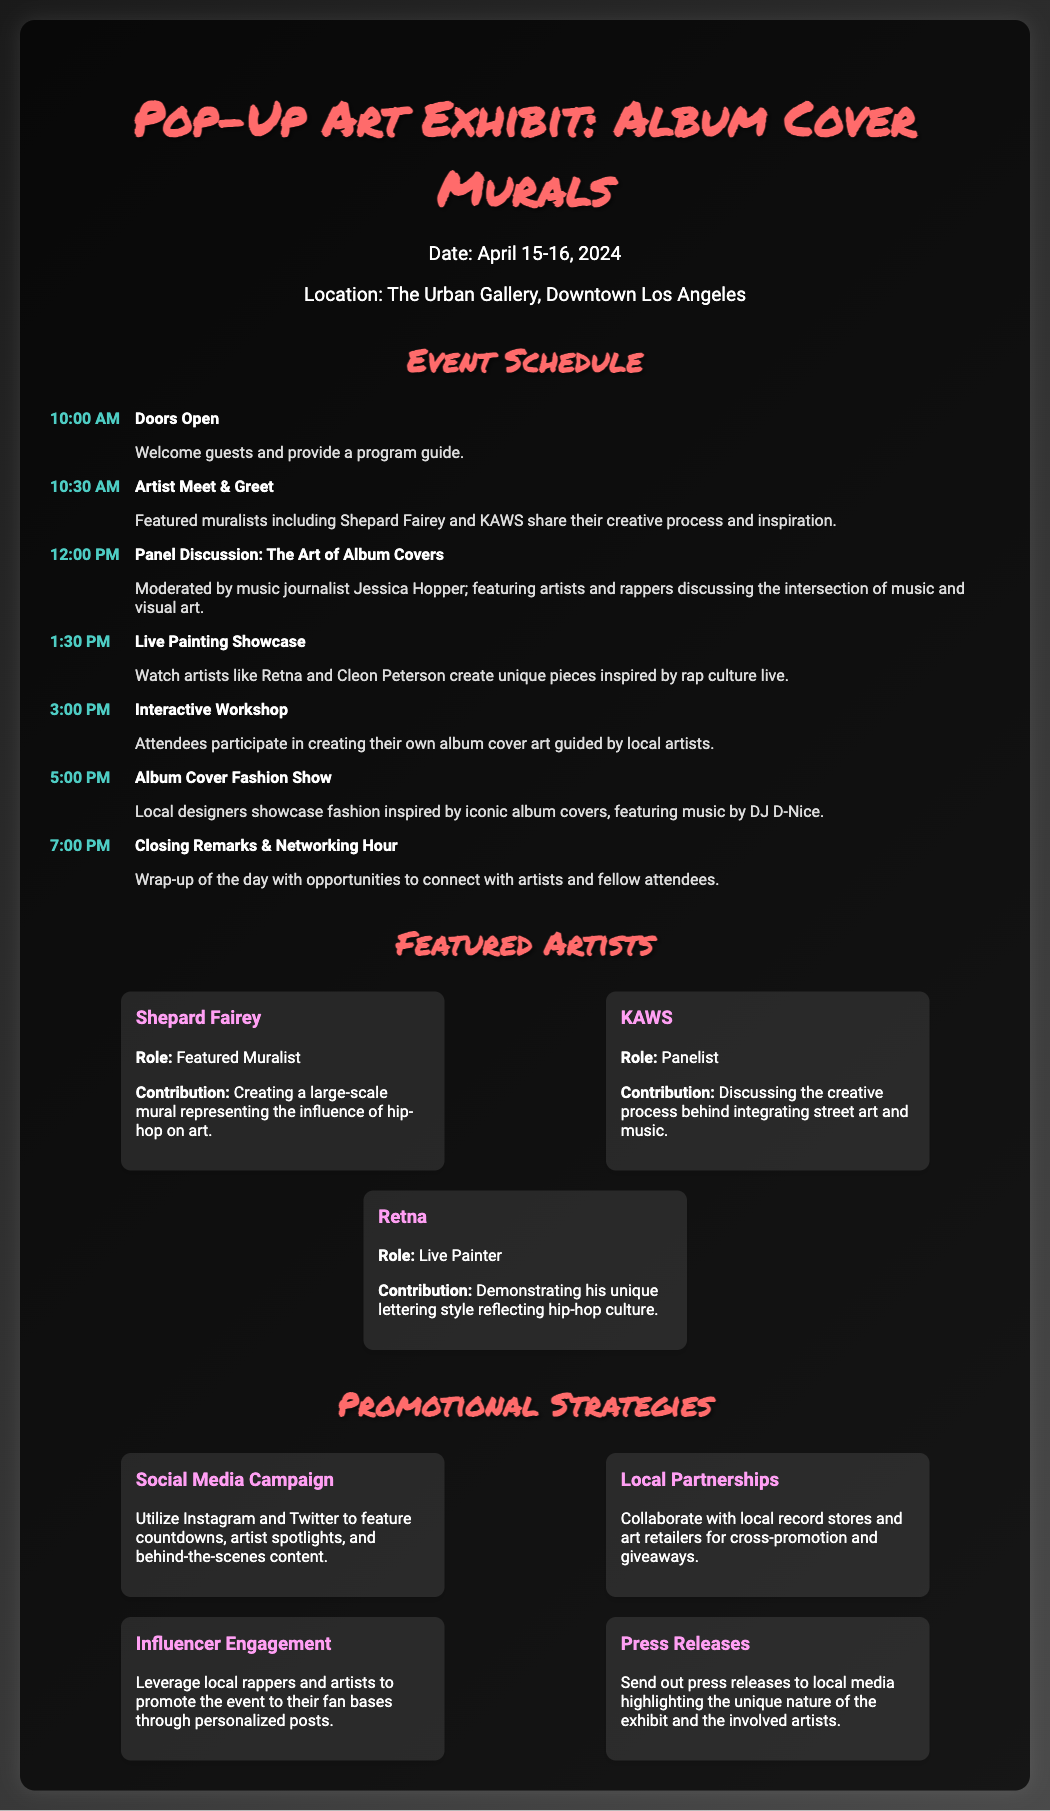What are the dates of the event? The dates of the event are listed in the event information section.
Answer: April 15-16, 2024 Who is the moderator for the panel discussion? The document provides specific information about who is leading the panel discussion.
Answer: Jessica Hopper What is the location of the pop-up art exhibit? The location is mentioned clearly in the event information section.
Answer: The Urban Gallery, Downtown Los Angeles How many featured artists are listed? The document contains a section with featured artists, and we can count them to answer this question.
Answer: 3 What activity starts at 1:30 PM? The agenda lists specific activities at different times, allowing us to find the answer.
Answer: Live Painting Showcase Which artist is creating a mural about hip-hop influence? The document specifies the contributions of each featured artist.
Answer: Shepard Fairey What promotional strategy involves local partnerships? The promotional strategies offered in the document include various approaches to engage the audience.
Answer: Local Partnerships How many total agenda items are listed? We can count the items in the agenda section to provide an accurate number.
Answer: 7 What time does the event close with remarks? The agenda specifies the time for closing remarks in the daily schedule.
Answer: 7:00 PM 